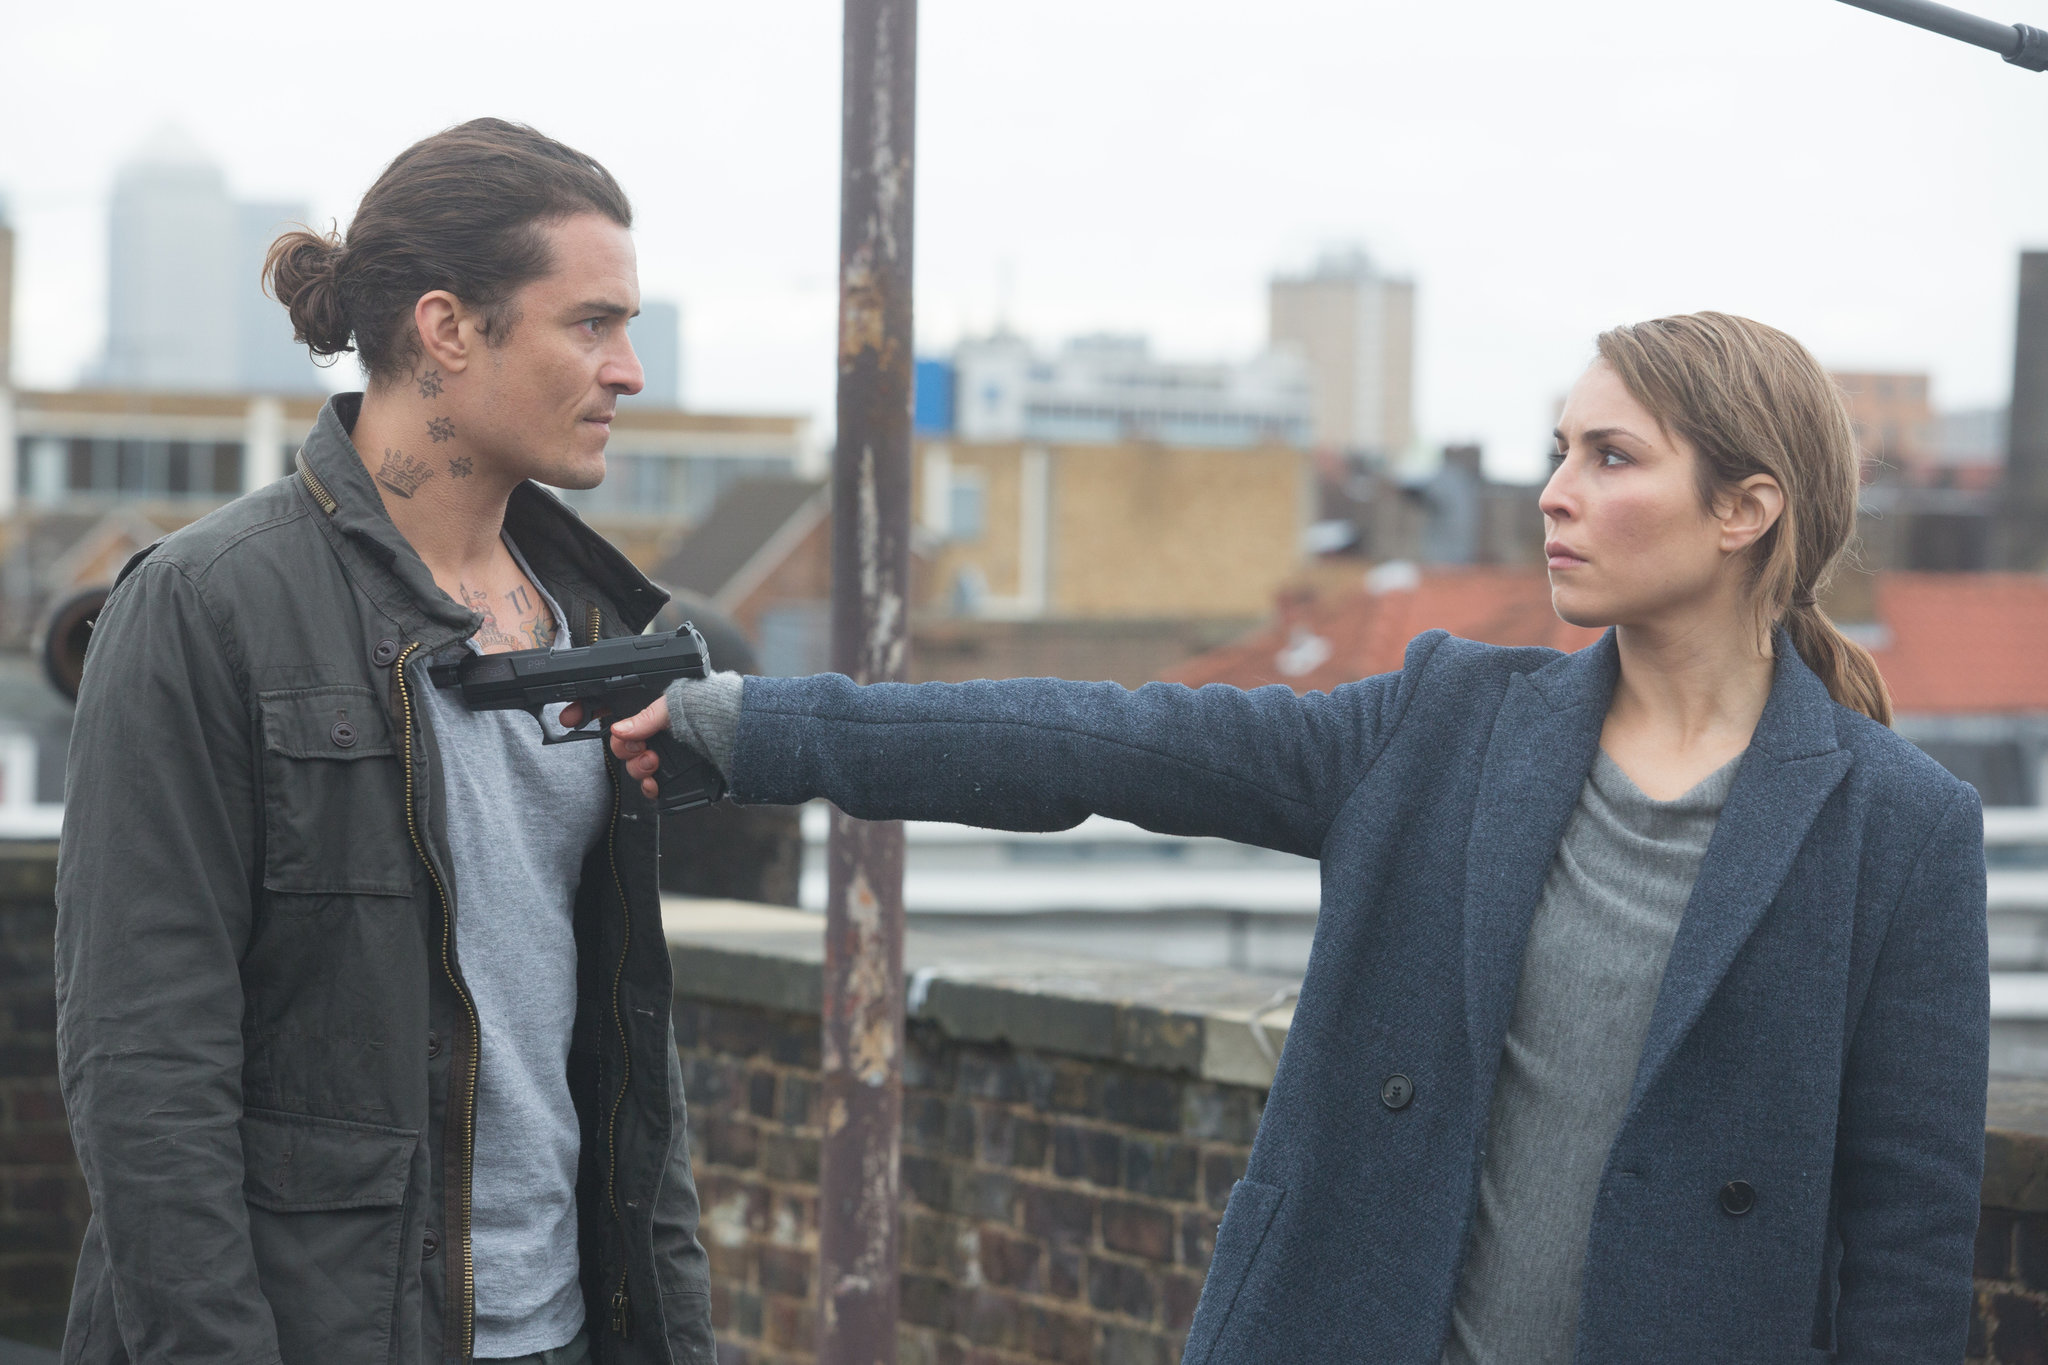Describe the following image. The image captures a gripping scene set on an urban rooftop. Noomi Rapace, embodying her role as Sam, confronts a male antagonist with resolute determination, her weapon directed firmly at him. He, marked by distinctive neck tattoos and clad in a rugged green jacket, faces her with an expression that mixes defiance with a hint of apprehension. The cloudy skyline not only contributes to the scene's tense atmosphere but also hints at the cinematic style typical of high-stakes thrillers. 